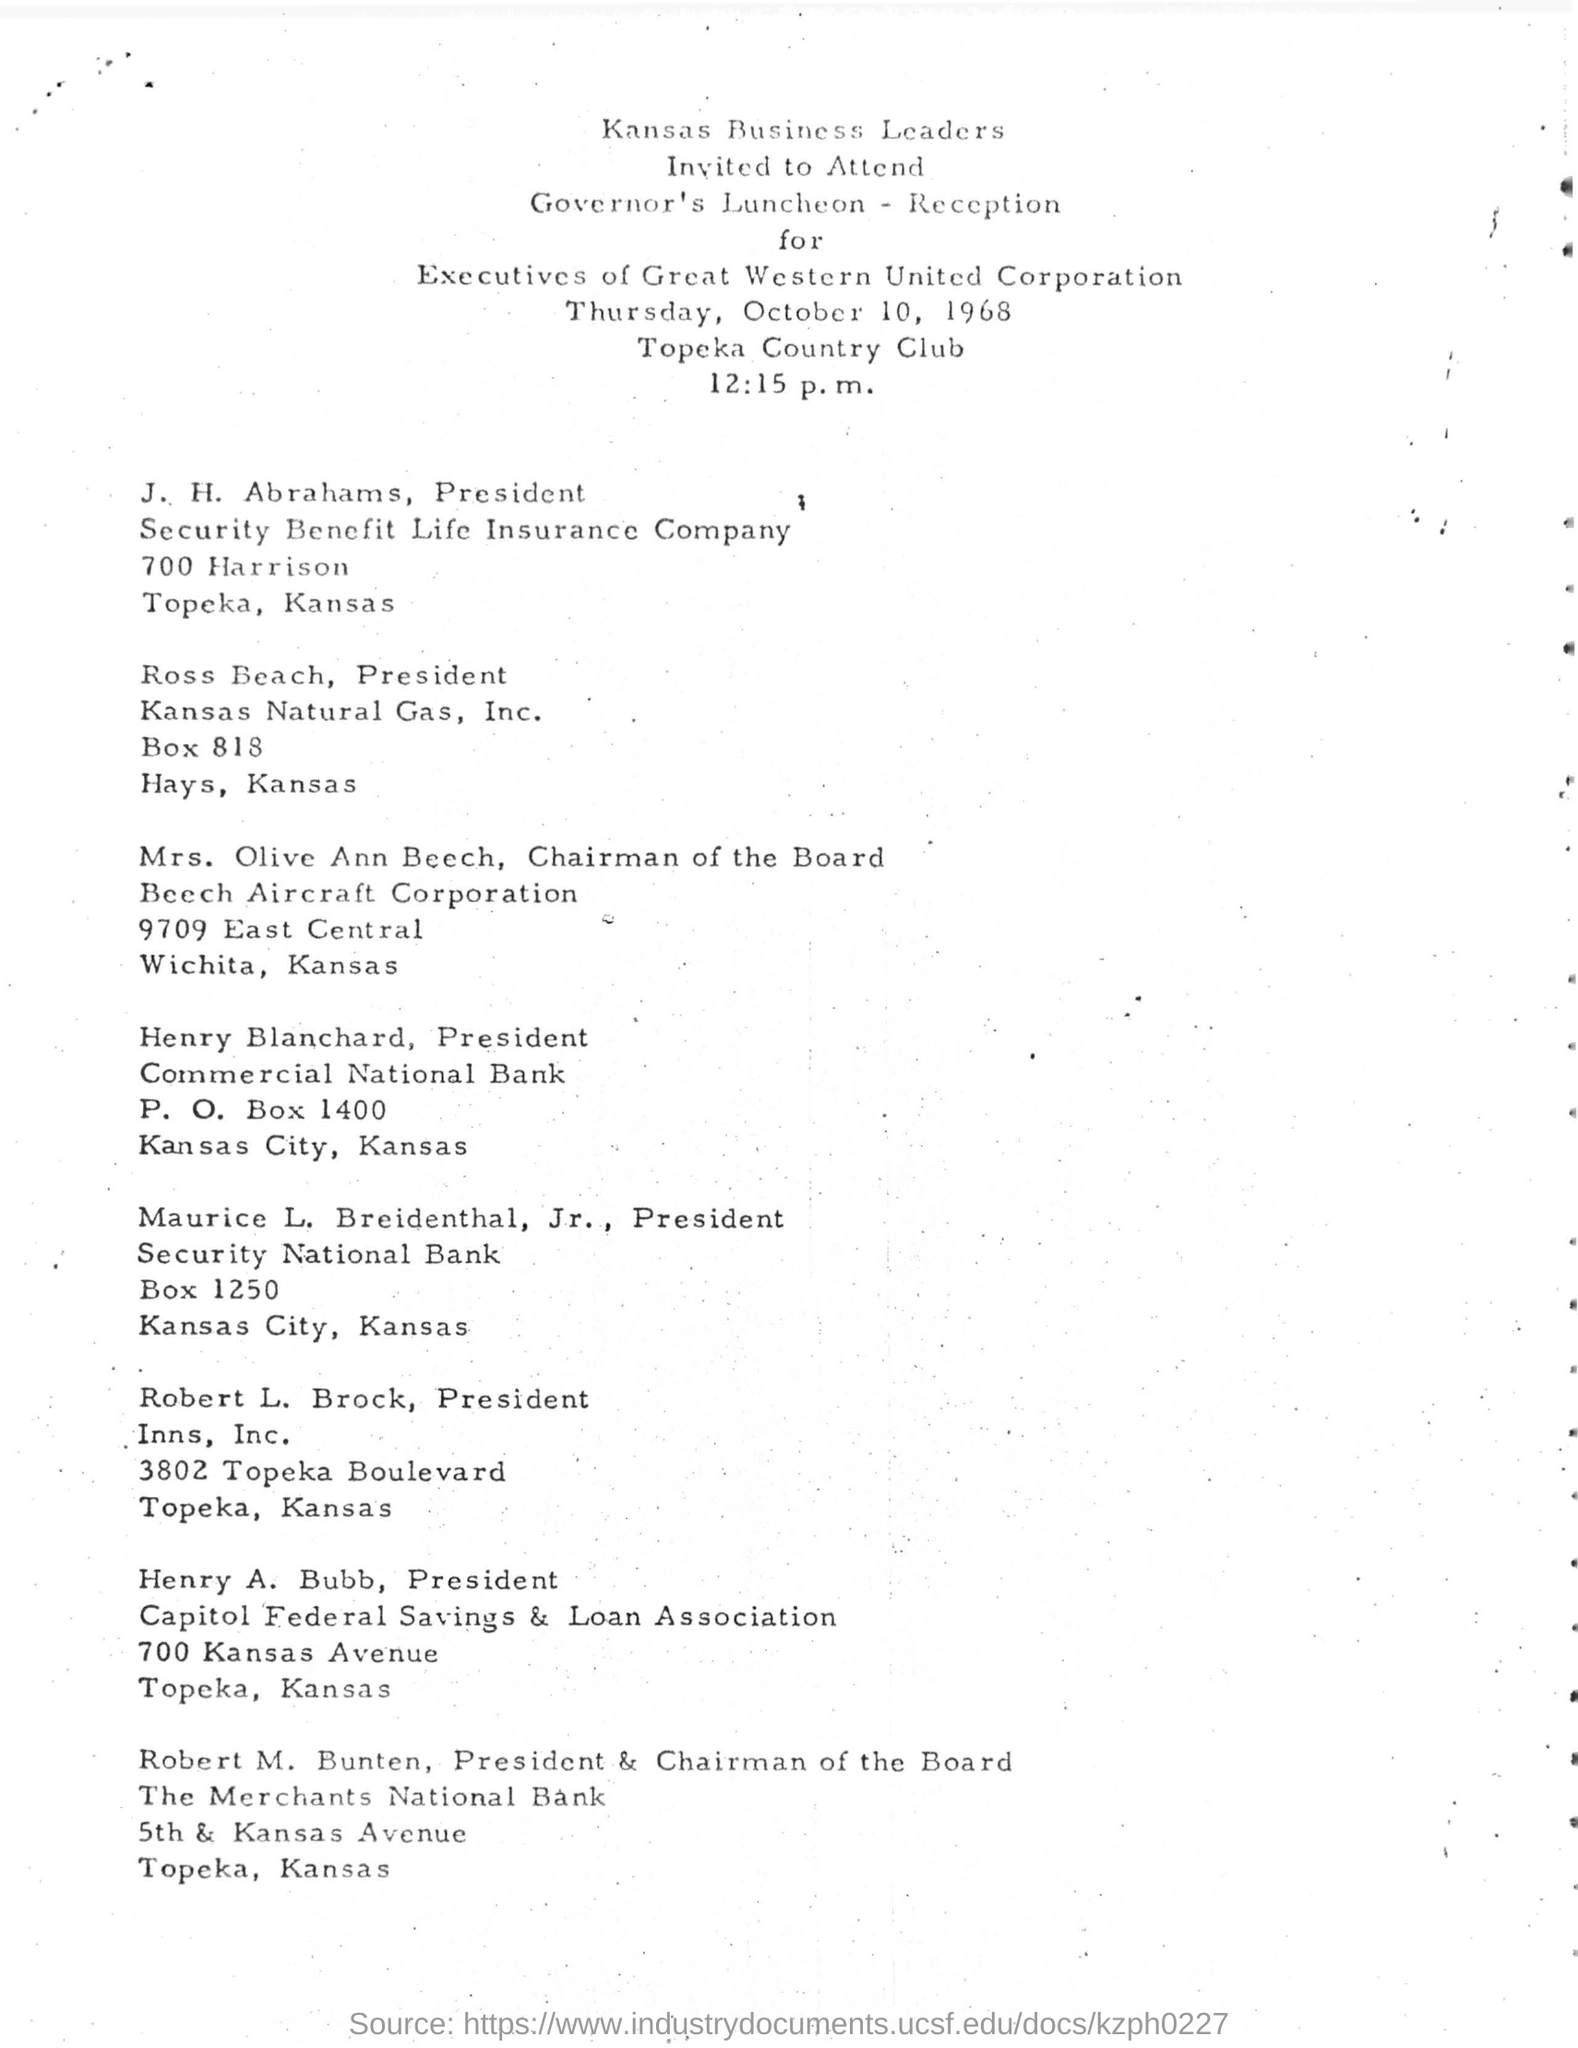Highlight a few significant elements in this photo. The time mentioned in this document is 12:15 p.m. October 10, 1968, was a Thursday. The P.O. box number of Henry Blachard, the President, is 1400. The date mentioned in the document is Thursday, October 10, 1968. 